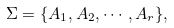Convert formula to latex. <formula><loc_0><loc_0><loc_500><loc_500>\Sigma = \{ A _ { 1 } , A _ { 2 } , \cdots , A _ { r } \} ,</formula> 